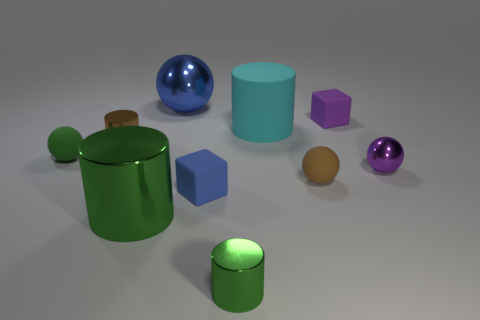The metal object to the right of the tiny brown thing to the right of the metal cylinder that is behind the small purple metallic object is what shape?
Provide a succinct answer. Sphere. The matte thing that is the same color as the large metallic ball is what shape?
Provide a succinct answer. Cube. What number of shiny balls are the same size as the brown shiny cylinder?
Your response must be concise. 1. Is there a large green cylinder left of the small brown thing that is left of the large green metallic cylinder?
Provide a succinct answer. No. What number of things are tiny purple rubber things or gray rubber spheres?
Your answer should be very brief. 1. The small shiny cylinder that is right of the tiny cube that is left of the matte object that is behind the cyan rubber cylinder is what color?
Keep it short and to the point. Green. Is there any other thing that is the same color as the big metallic ball?
Offer a very short reply. Yes. Is the cyan cylinder the same size as the blue metal ball?
Ensure brevity in your answer.  Yes. What number of objects are either shiny objects that are left of the big green shiny thing or tiny metal cylinders to the left of the tiny green shiny thing?
Give a very brief answer. 1. What is the material of the brown object that is to the right of the rubber block that is in front of the tiny green sphere?
Your answer should be compact. Rubber. 